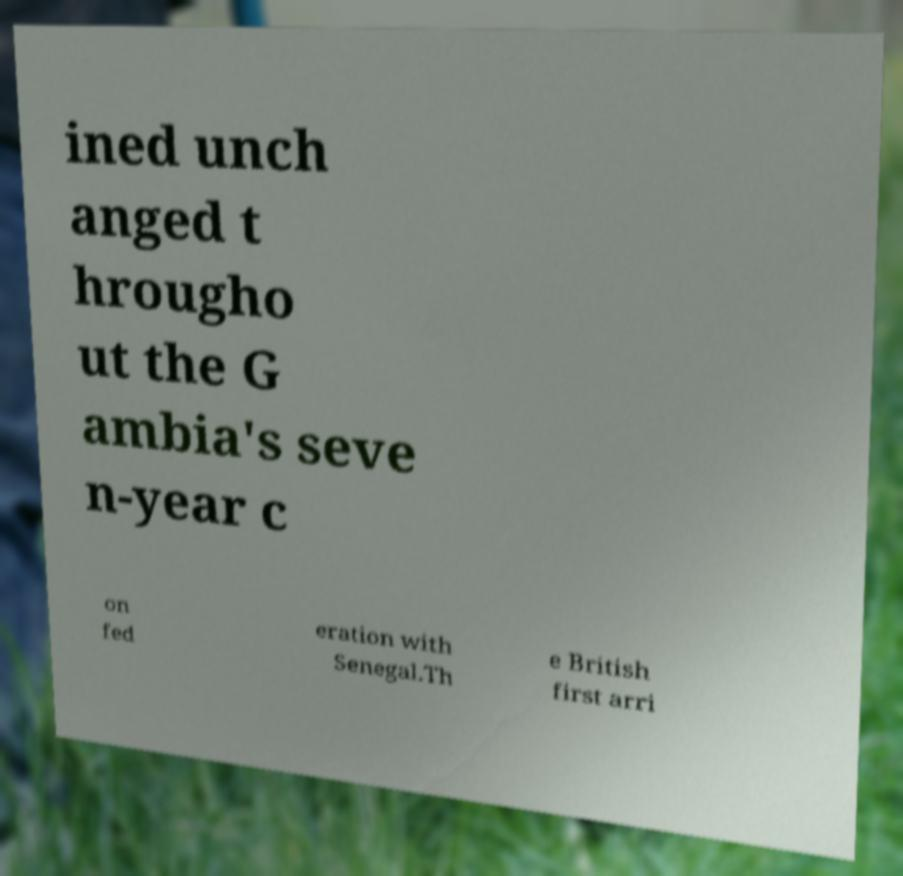Could you assist in decoding the text presented in this image and type it out clearly? ined unch anged t hrougho ut the G ambia's seve n-year c on fed eration with Senegal.Th e British first arri 